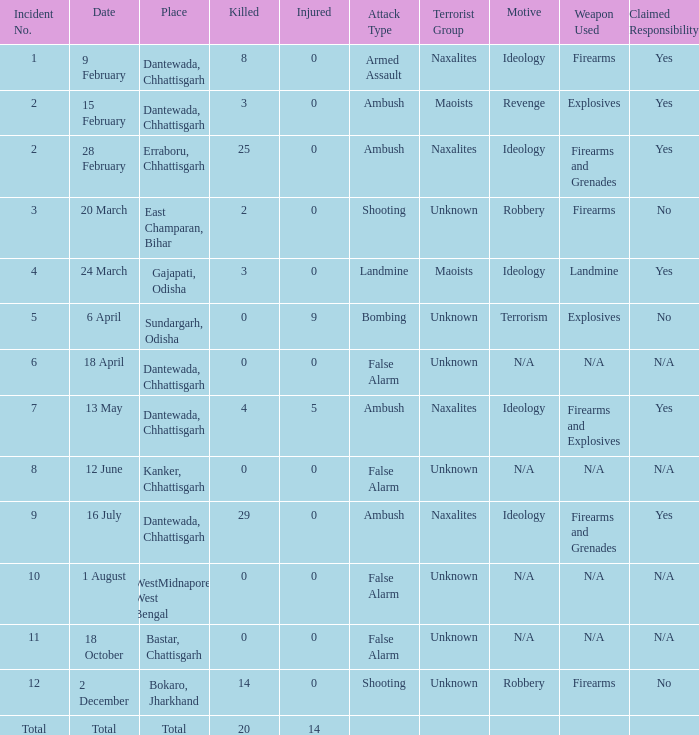What is the least amount of injuries in Dantewada, Chhattisgarh when 8 people were killed? 0.0. 